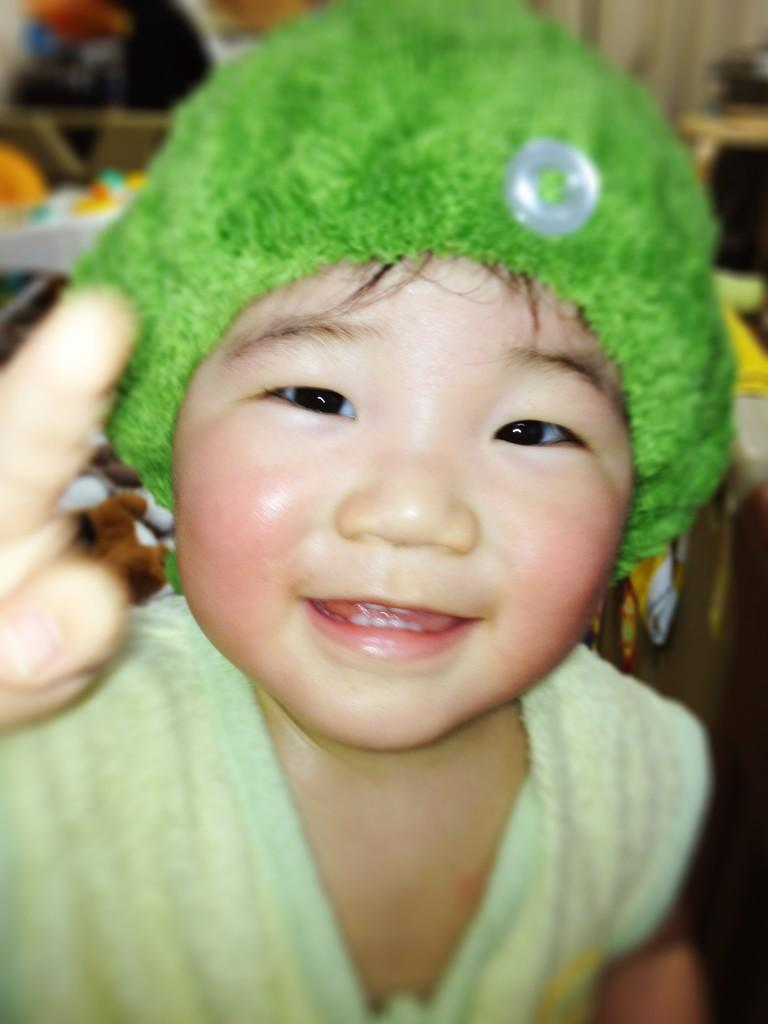What is the main subject of the image? The main subject of the image is a child. Can you describe the child's clothing in the image? The child is wearing a green cap and a green dress. How many geese are visible in the image? There are no geese present in the image. What type of kitty can be seen playing with the child in the image? There is no kitty present in the image. 